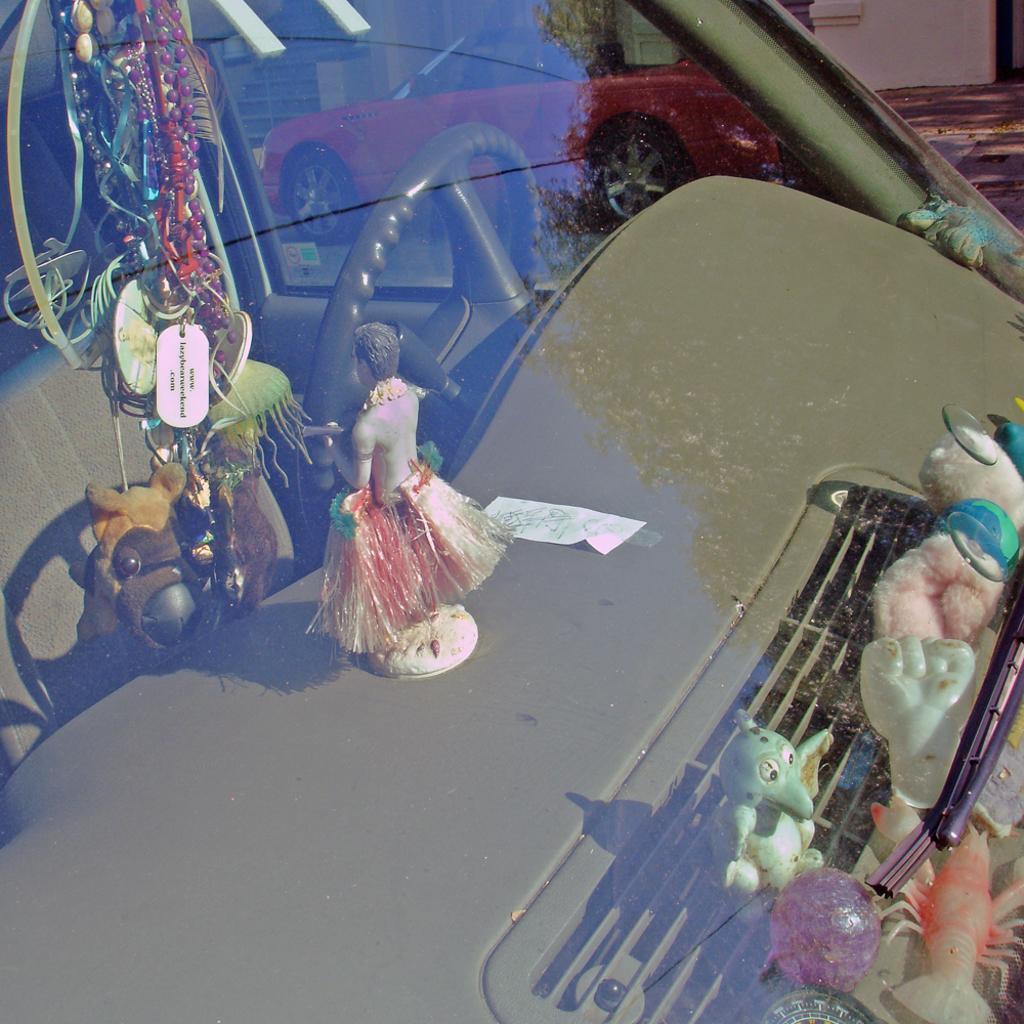How would you summarize this image in a sentence or two? This picture might be taken from outside of the glass window. In this image, in the middle, we can see a toy, inside the glass window, we can see a steering. In the background, we can also see another car. 